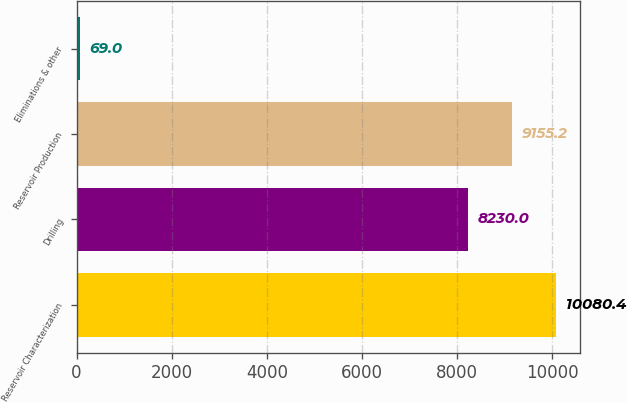Convert chart to OTSL. <chart><loc_0><loc_0><loc_500><loc_500><bar_chart><fcel>Reservoir Characterization<fcel>Drilling<fcel>Reservoir Production<fcel>Eliminations & other<nl><fcel>10080.4<fcel>8230<fcel>9155.2<fcel>69<nl></chart> 